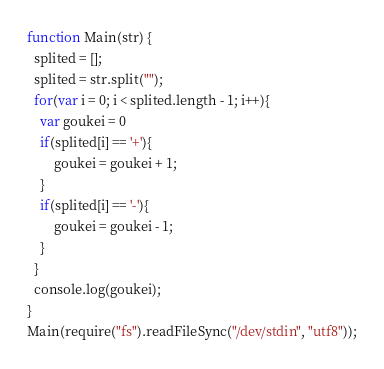Convert code to text. <code><loc_0><loc_0><loc_500><loc_500><_JavaScript_>function Main(str) {
  splited = [];
  splited = str.split("");
  for(var i = 0; i < splited.length - 1; i++){
    var goukei = 0
    if(splited[i] == '+'){
        goukei = goukei + 1;
    }
    if(splited[i] == '-'){
        goukei = goukei - 1;
    }
  }
  console.log(goukei);
}
Main(require("fs").readFileSync("/dev/stdin", "utf8"));</code> 